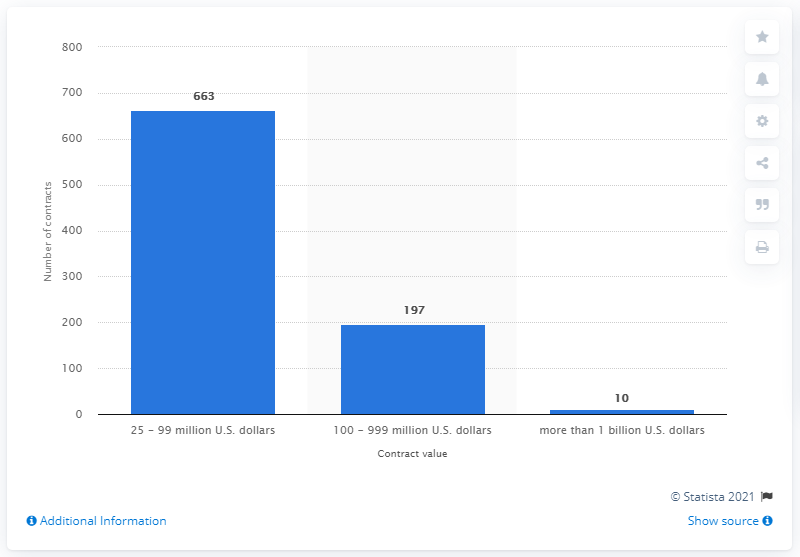Specify some key components in this picture. In 2011, there were 663 contracts with a value of 25 to 99 million U.S. dollars. 